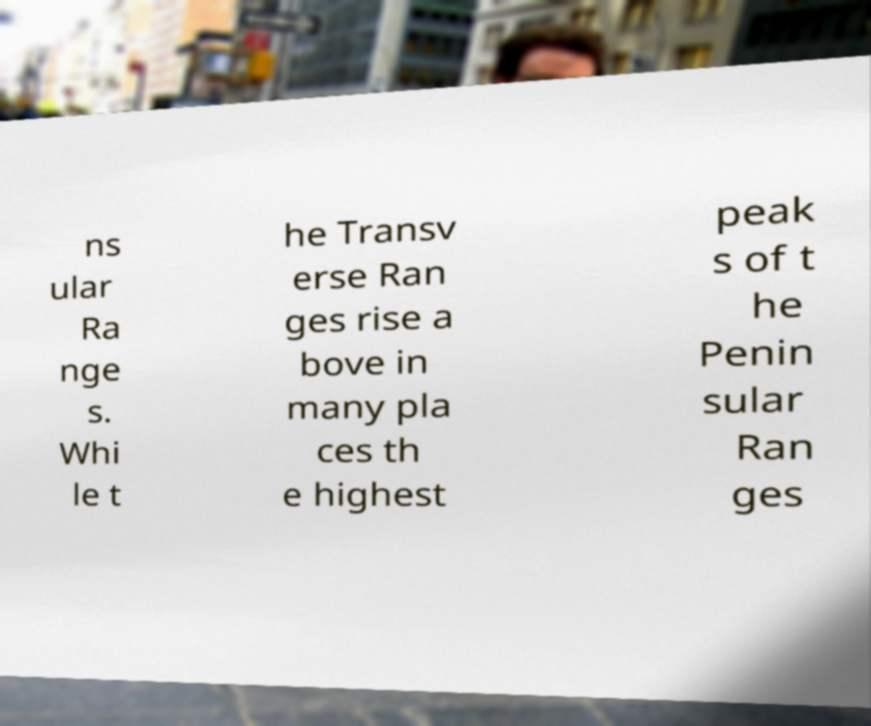Please read and relay the text visible in this image. What does it say? ns ular Ra nge s. Whi le t he Transv erse Ran ges rise a bove in many pla ces th e highest peak s of t he Penin sular Ran ges 